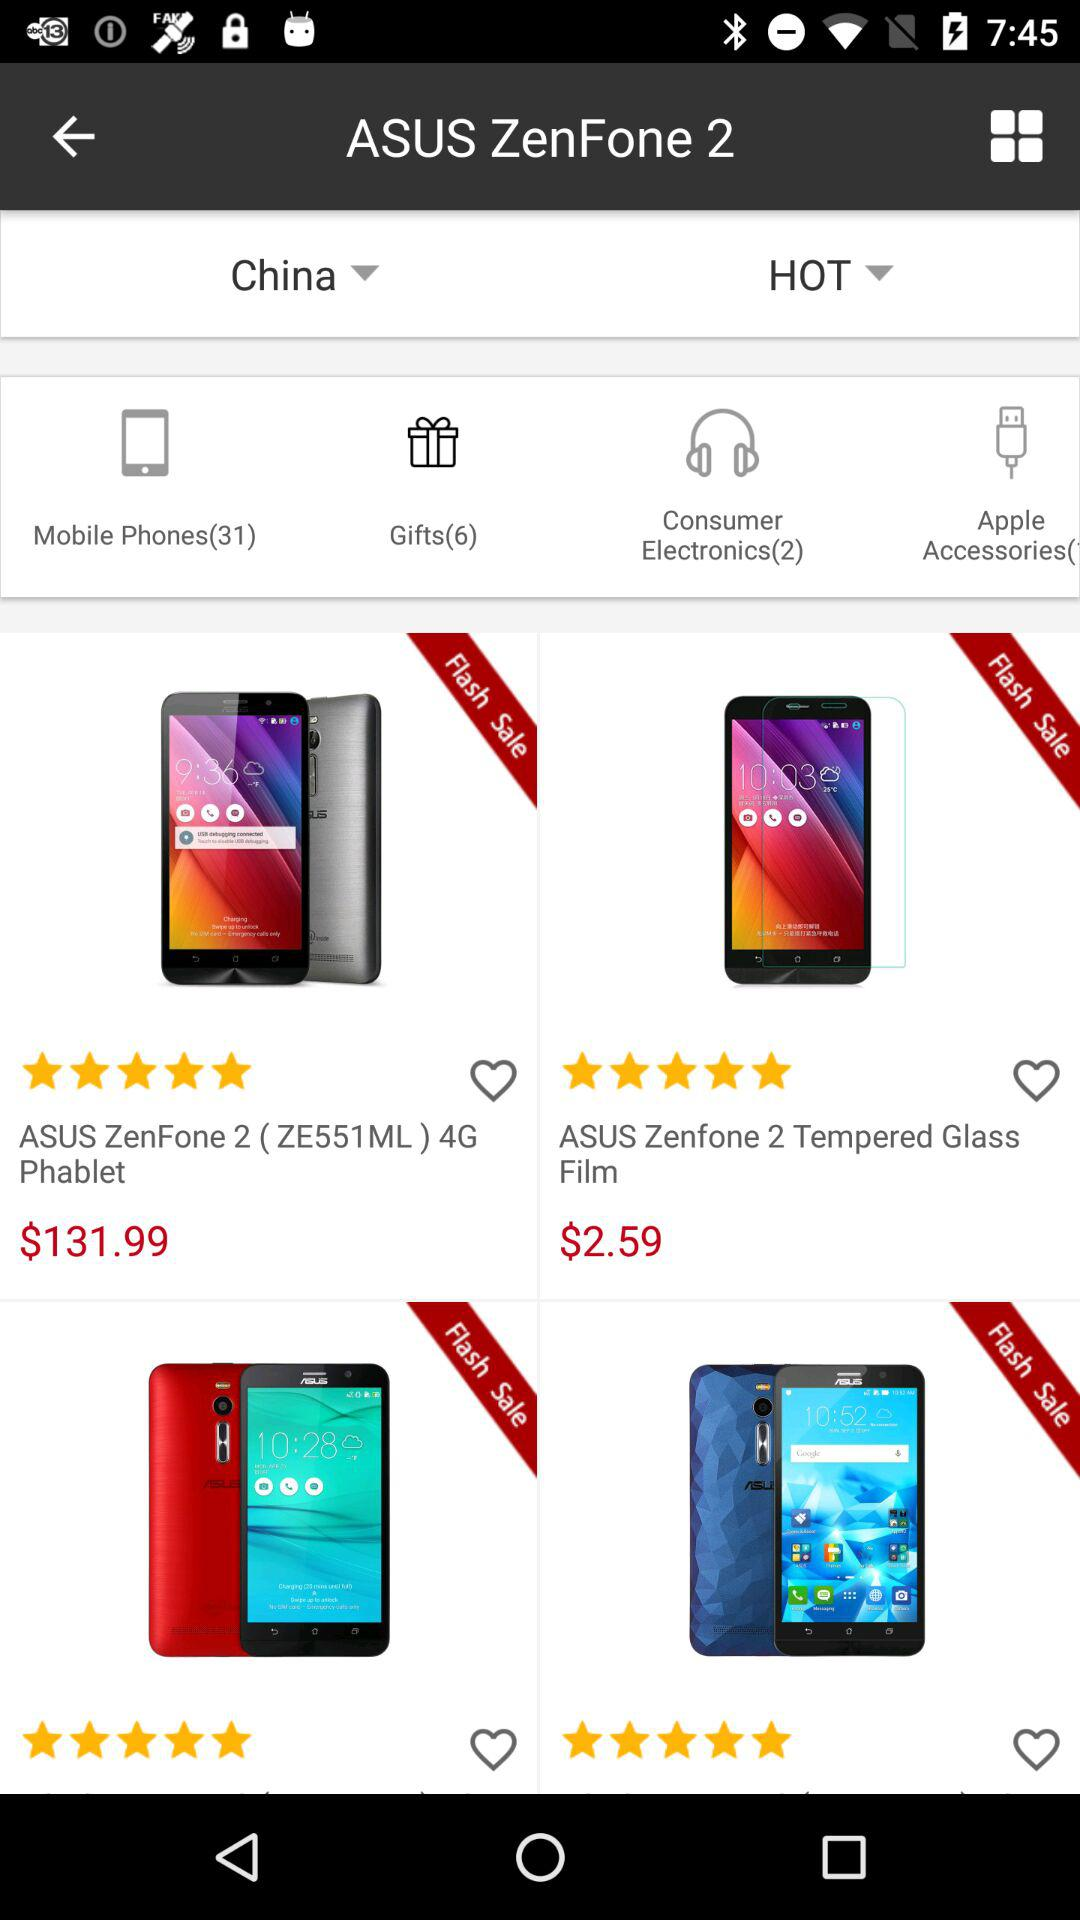What is the cost of "ASUS Zenfone 2 Tempered Glass Film"? The cost is $2.59. 